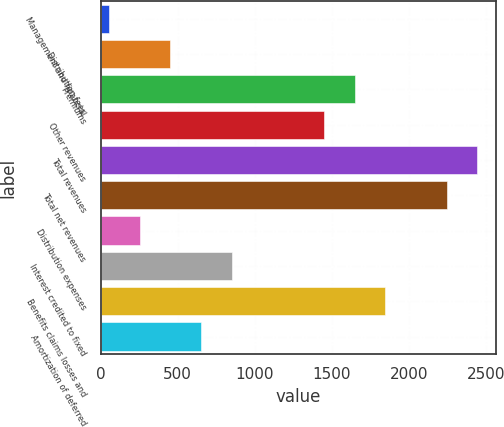Convert chart to OTSL. <chart><loc_0><loc_0><loc_500><loc_500><bar_chart><fcel>Management and financial<fcel>Distribution fees<fcel>Premiums<fcel>Other revenues<fcel>Total revenues<fcel>Total net revenues<fcel>Distribution expenses<fcel>Interest credited to fixed<fcel>Benefits claims losses and<fcel>Amortization of deferred<nl><fcel>54<fcel>452.6<fcel>1648.4<fcel>1449.1<fcel>2445.6<fcel>2246.3<fcel>253.3<fcel>851.2<fcel>1847.7<fcel>651.9<nl></chart> 